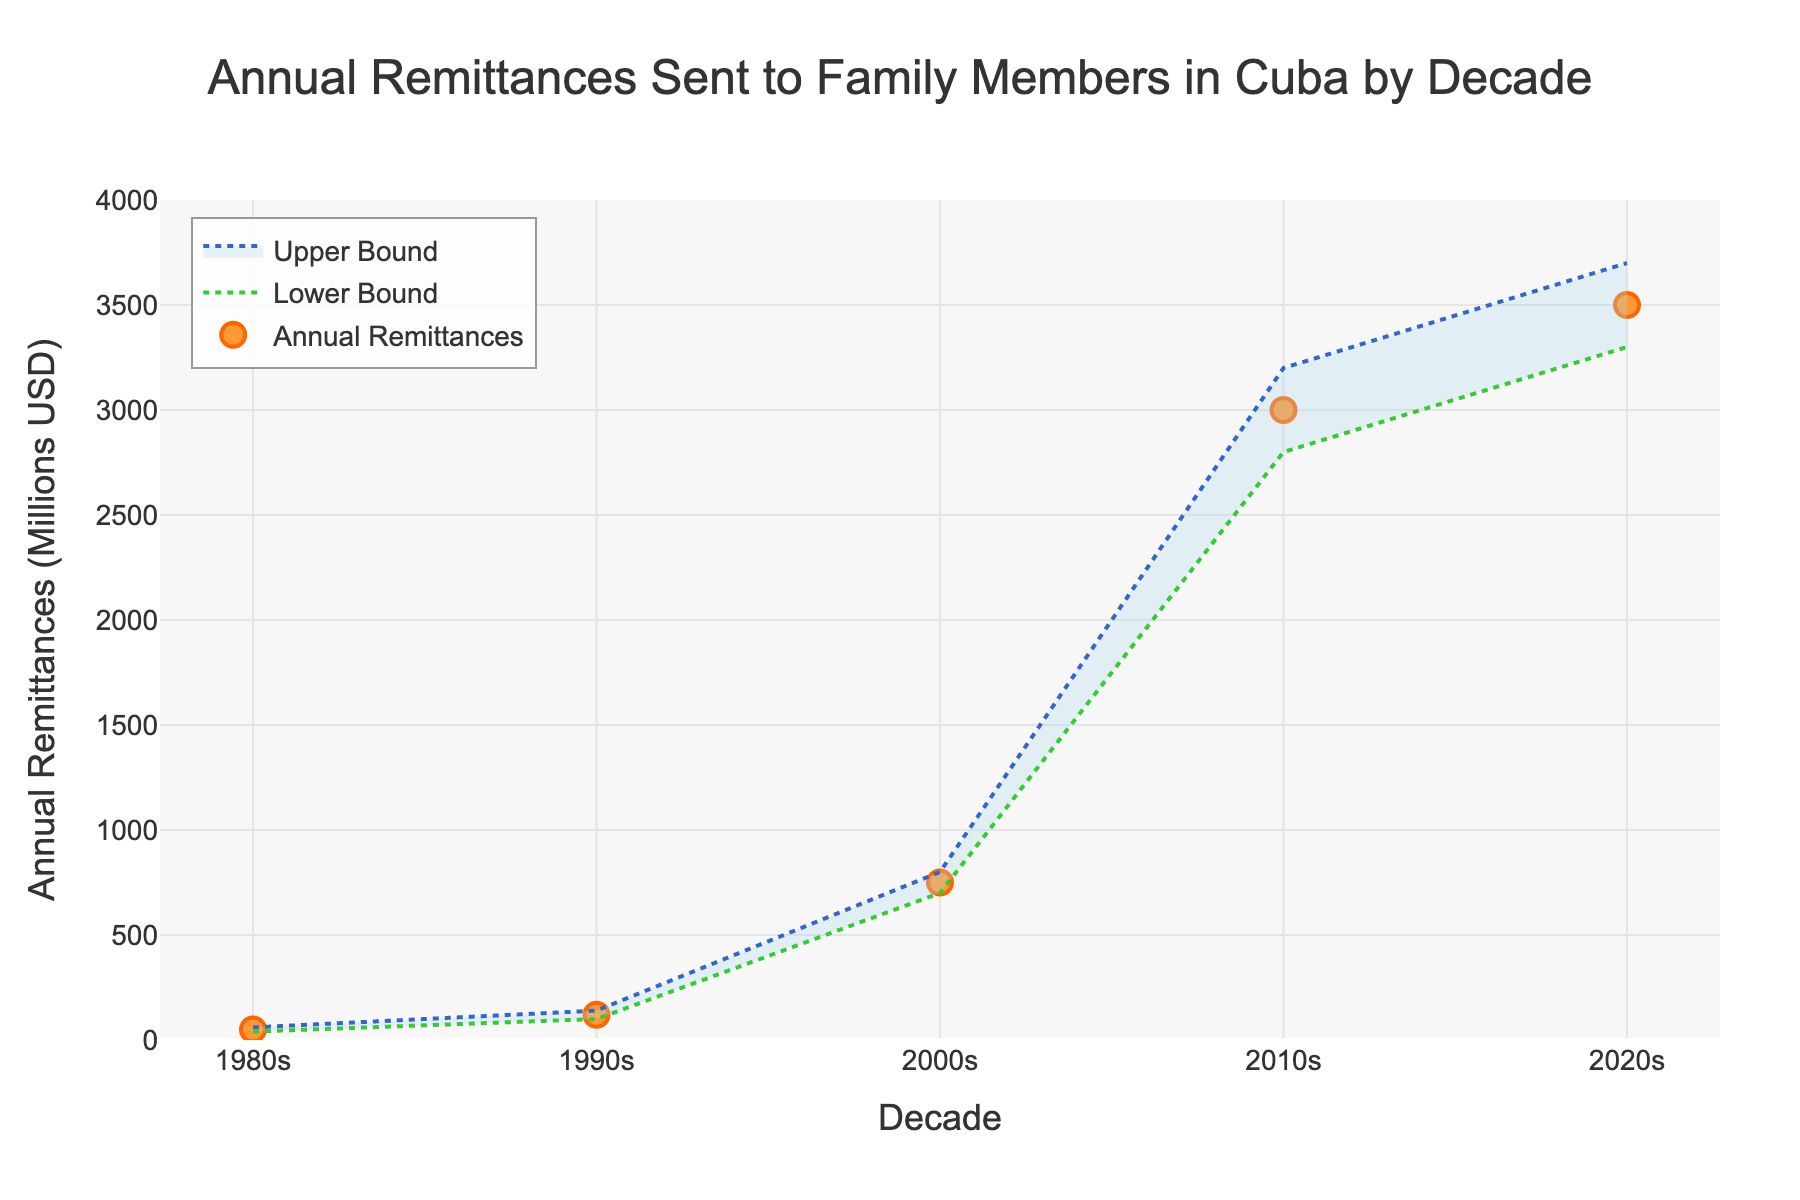What is the title of the plot? The title of the plot is displayed at the top center of the figure. It reads, "Annual Remittances Sent to Family Members in Cuba by Decade."
Answer: Annual Remittances Sent to Family Members in Cuba by Decade How many decades are represented in the plot? By looking along the x-axis, which represents decades, we can count the data points labeled. There are five: 1980s, 1990s, 2000s, 2010s, and 2020s.
Answer: 5 What is the approximate range of annual remittances for the 2020s? The plot shows a shaded area with lines representing the lower and upper bounds for each decade. For the 2020s, the lower bound is at 3300 million USD, and the upper bound is at 3700 million USD.
Answer: 3300 to 3700 million USD Which decade shows the highest average annual remittances? By comparing the markers representing average remittances for each decade, the 2020s have the highest value at 3500 million USD.
Answer: 2020s How did annual remittances change from the 2000s to the 2010s? Comparing the markers for the 2000s and 2010s shows that annual remittances increased from 750 million USD in the 2000s to 3000 million USD in the 2010s. This is an increase of 2250 million USD.
Answer: Increased by 2250 million USD What is the trend in annual remittances from the 1980s to the 2020s? Observing the markers across each decade from left to right (1980s to 2020s), there is a clear increasing trend in annual remittances. The values rise consistently across the decades.
Answer: Increasing trend Which decade has the closest lower and upper bounds? Comparing the distances between lower and upper bounds across all decades, the 1980s have the smallest range, from 40 million USD to 60 million USD, which is a range of 20 million USD.
Answer: 1980s How much greater is the upper bound in the 2010s compared to the upper bound in the 1990s? The upper bound for the 2010s is 3200 million USD, and for the 1990s, it is 140 million USD. The difference between them is 3200 - 140 = 3060 million USD.
Answer: 3060 million USD What decade experienced the most significant increase in average remittances compared to its preceding decade? By examining the difference in average remittances from one decade to the next, the 2000s to the 2010s shows the most significant increase, from 750 million USD to 3000 million USD, a difference of 2250 million USD.
Answer: 2000s to 2010s What is the general relationship between the average annual remittances and their lower and upper bounds for each decade? The figure indicates that the lower and upper bounds form a range within which the average annual remittances fall. This shows that there is variability around the average, depicted by the distance between the lower and upper bound lines.
Answer: Bounds encompass the average 